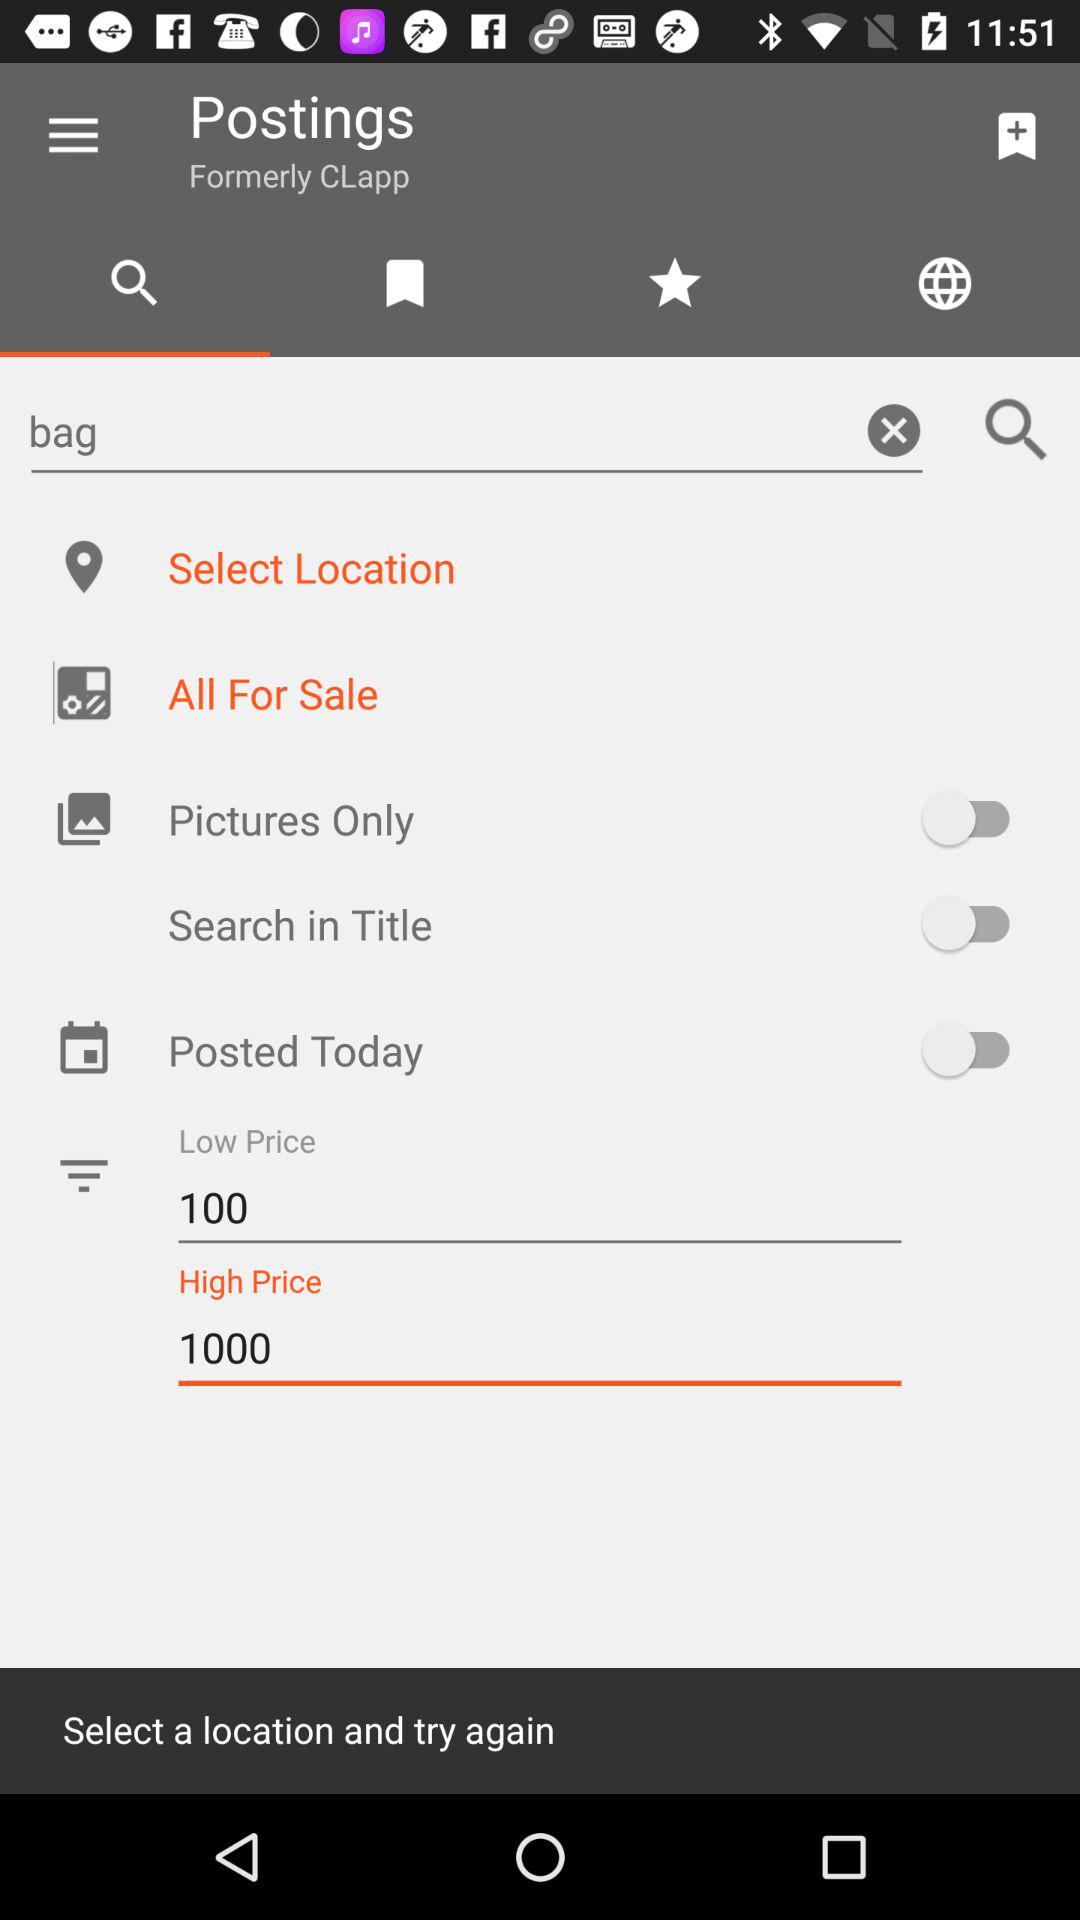What is the low price amount? The low price amount is 100. 